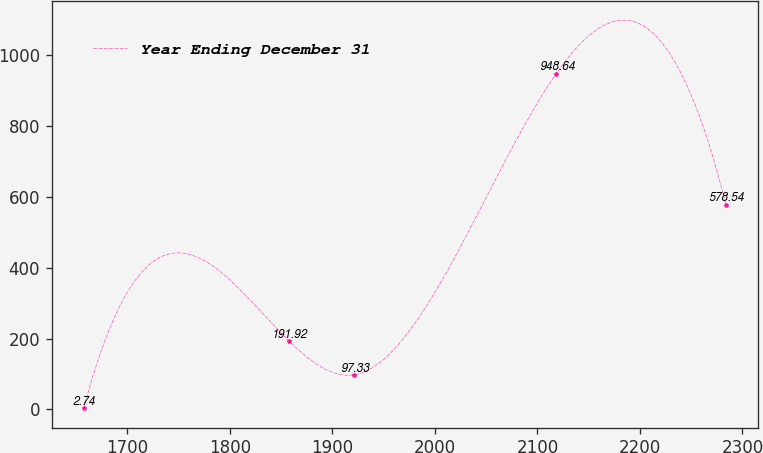Convert chart. <chart><loc_0><loc_0><loc_500><loc_500><line_chart><ecel><fcel>Year Ending December 31<nl><fcel>1657.49<fcel>2.74<nl><fcel>1858.13<fcel>191.92<nl><fcel>1921.16<fcel>97.33<nl><fcel>2118.36<fcel>948.64<nl><fcel>2283.87<fcel>578.54<nl></chart> 